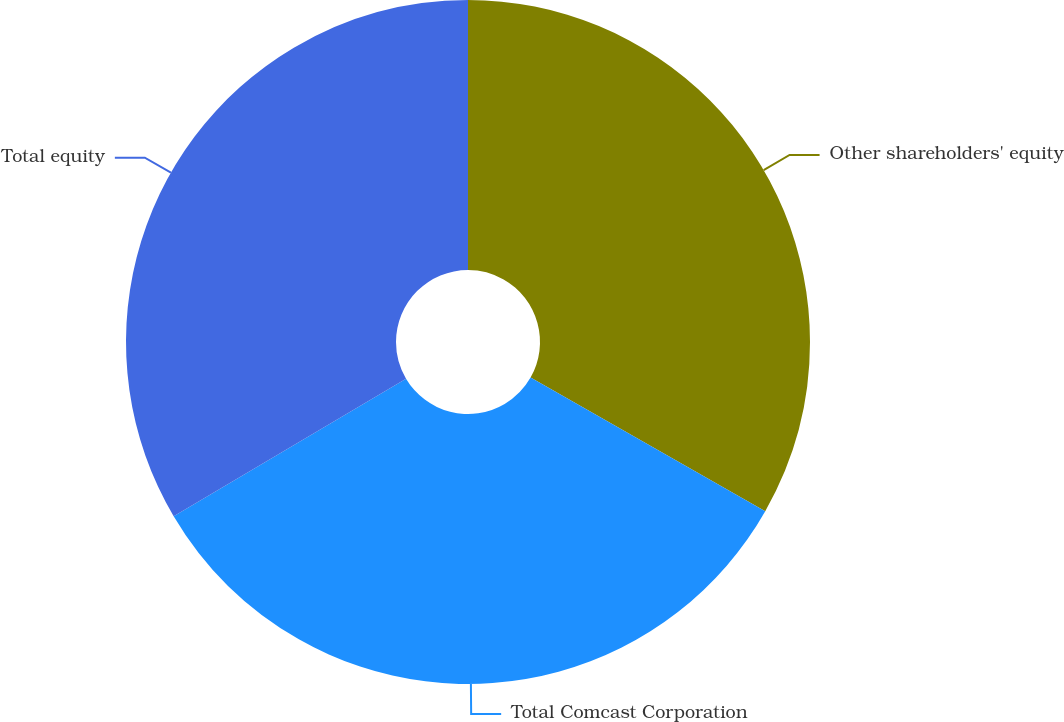Convert chart to OTSL. <chart><loc_0><loc_0><loc_500><loc_500><pie_chart><fcel>Other shareholders' equity<fcel>Total Comcast Corporation<fcel>Total equity<nl><fcel>33.23%<fcel>33.26%<fcel>33.5%<nl></chart> 